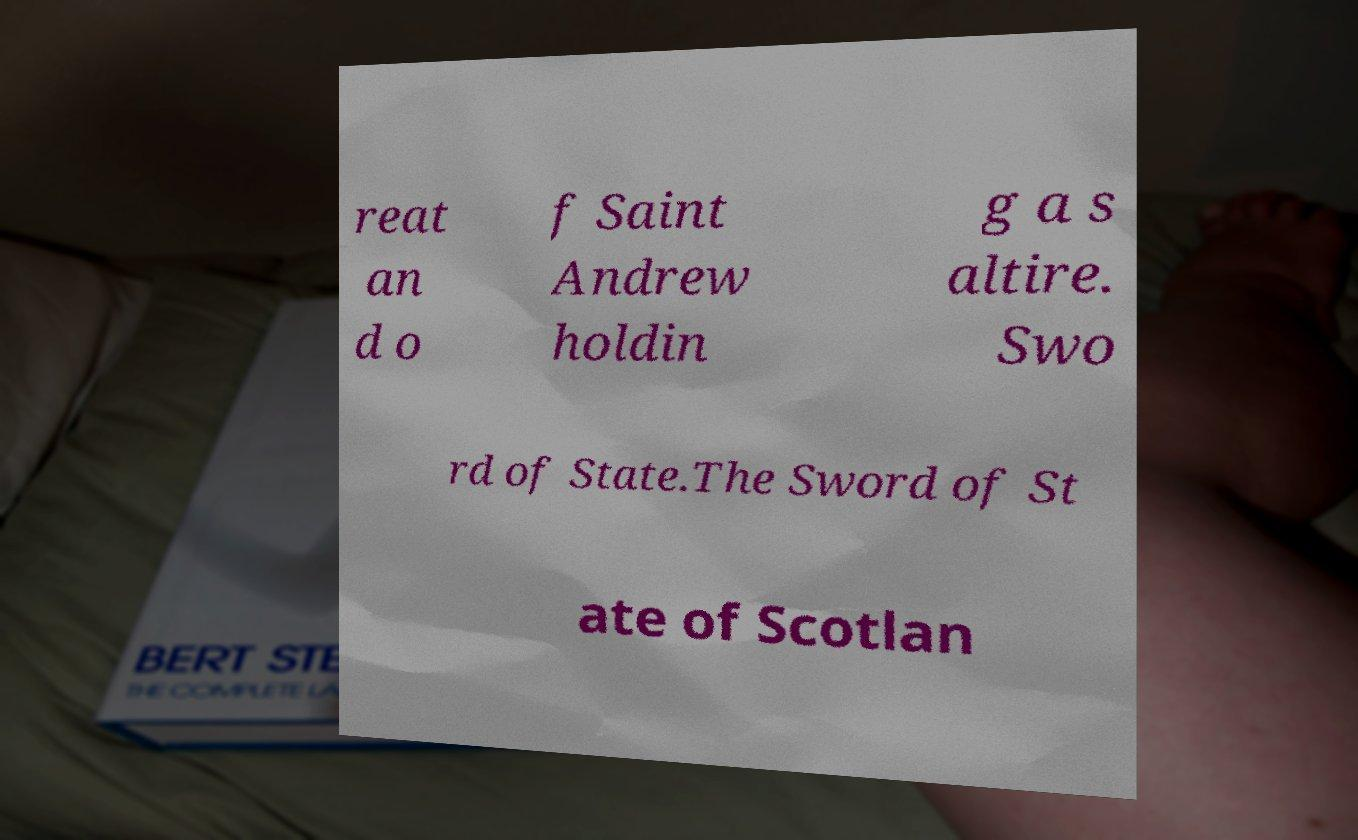Could you extract and type out the text from this image? reat an d o f Saint Andrew holdin g a s altire. Swo rd of State.The Sword of St ate of Scotlan 